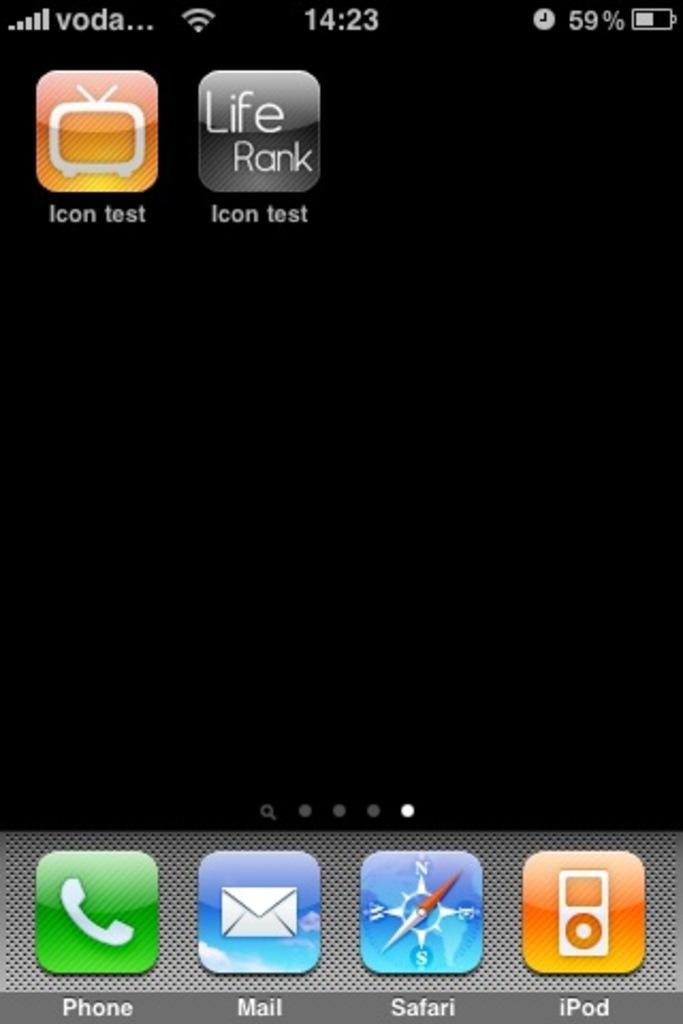<image>
Provide a brief description of the given image. A smartphone screen shows icon test for the apps. 